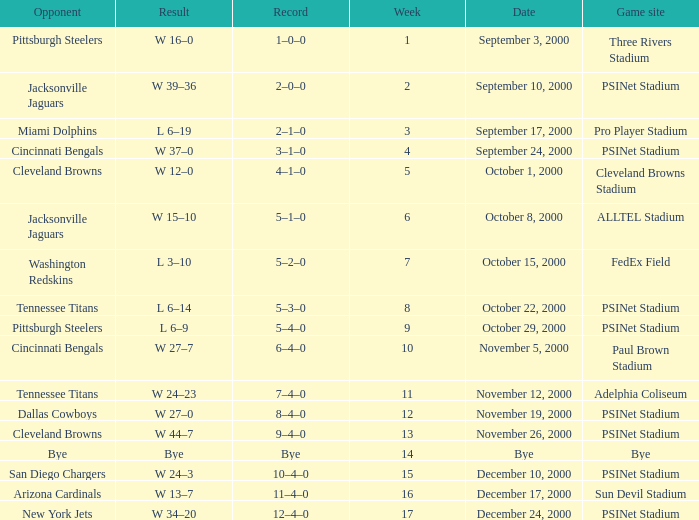What's the record for October 8, 2000 before week 13? 5–1–0. 